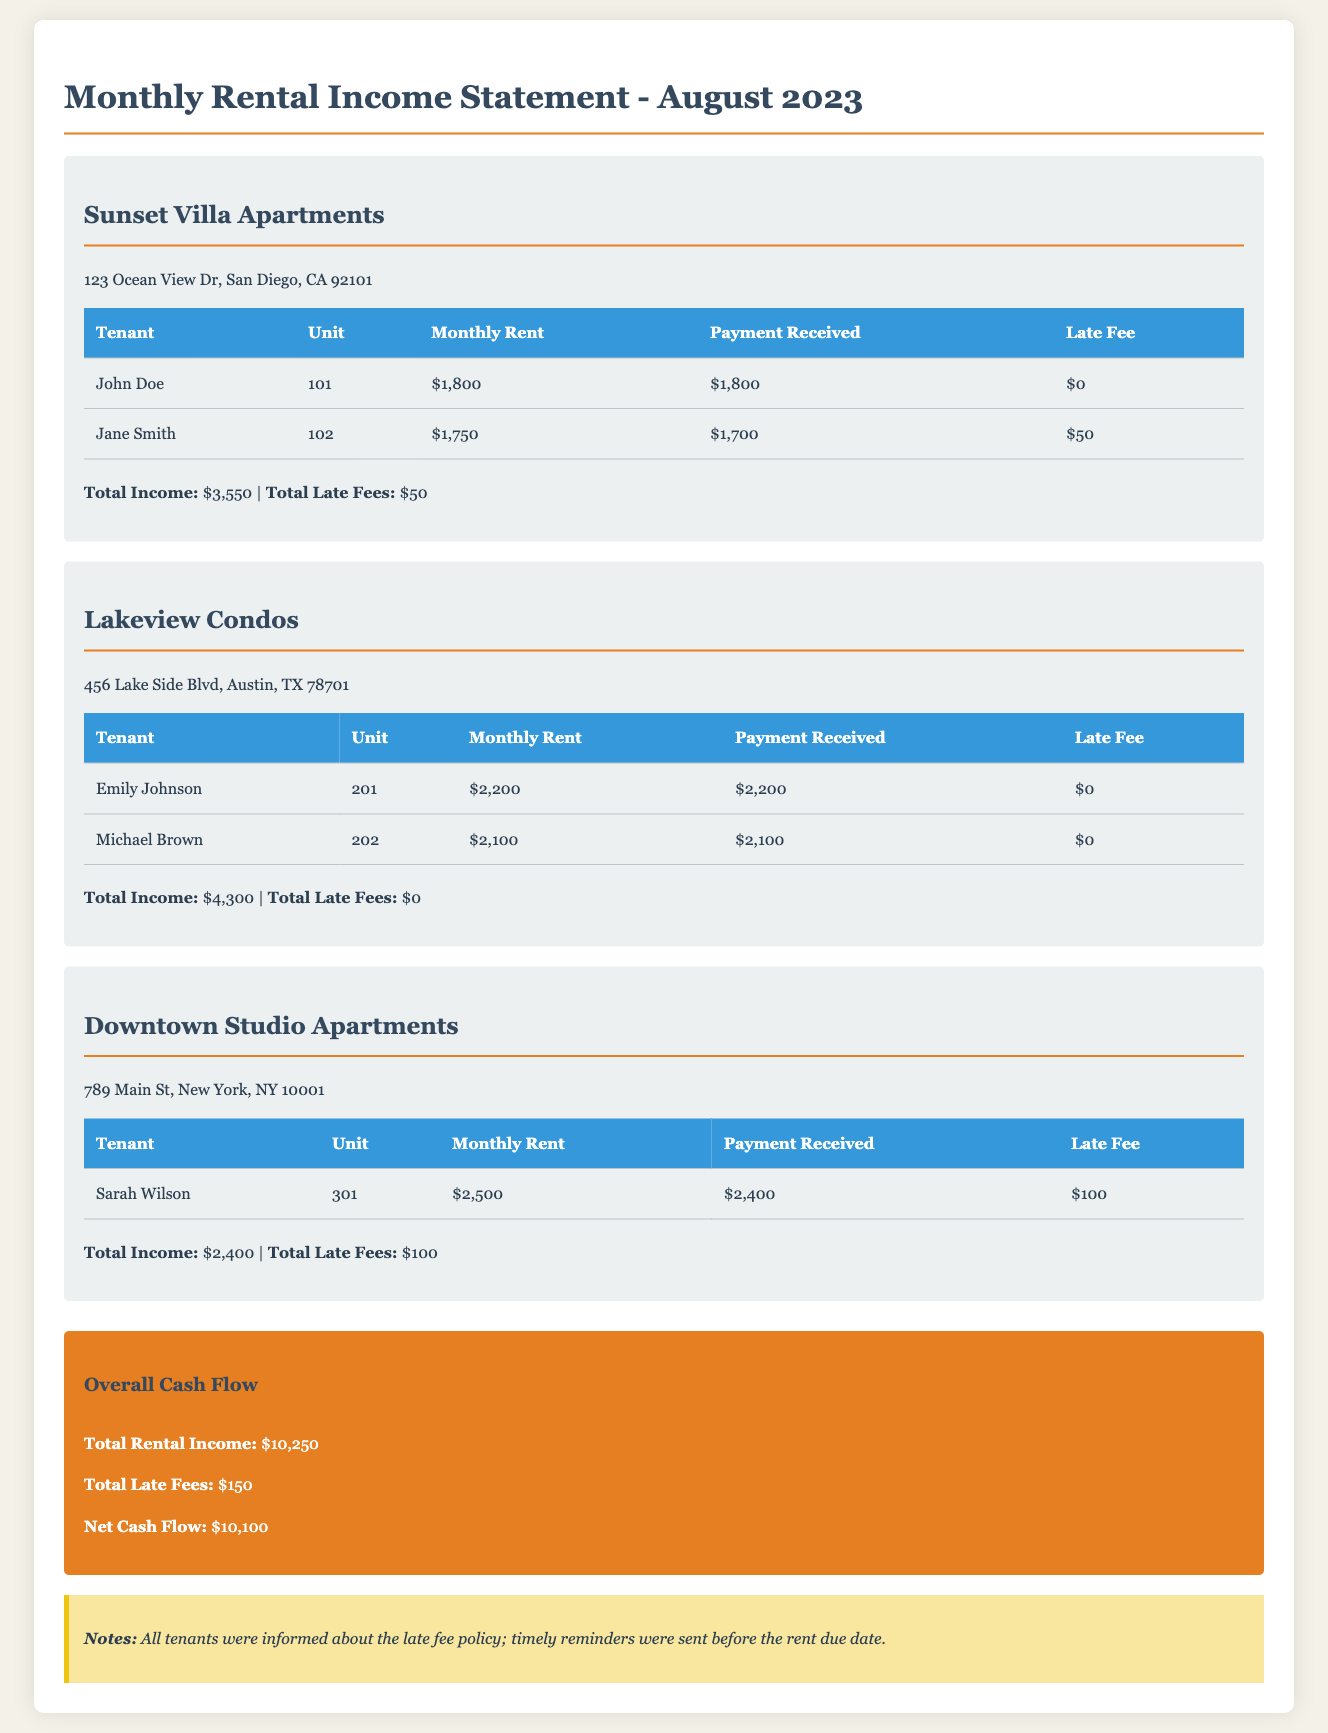What is the total income from Sunset Villa Apartments? The total income from Sunset Villa Apartments is listed in the document as $3,550.
Answer: $3,550 How much did Jane Smith pay? The payment received by Jane Smith is stated in the document as $1,700.
Answer: $1,700 What late fee was applied for Sarah Wilson? The document notes a late fee of $100 was applied for Sarah Wilson.
Answer: $100 What is the net cash flow for August 2023? The net cash flow is calculated as total rental income minus total late fees, which is $10,250 - $150.
Answer: $10,100 Which property generated the highest rental income? The property with the highest rental income can be deduced from the individual totals; Lakeview Condos generated $4,300, which is the highest.
Answer: Lakeview Condos What is the total amount of late fees for all properties? The document summarizes the total late fees collected from all properties as $150.
Answer: $150 What was Emily Johnson's unit number? The document indicates that Emily Johnson resides in unit 201.
Answer: 201 What is the address of Downtown Studio Apartments? The address for Downtown Studio Apartments is given in the document as 789 Main St, New York, NY 10001.
Answer: 789 Main St, New York, NY 10001 How many tenants were charged late fees? The document details that there were two tenants who incurred late fees (Jane Smith and Sarah Wilson).
Answer: Two 